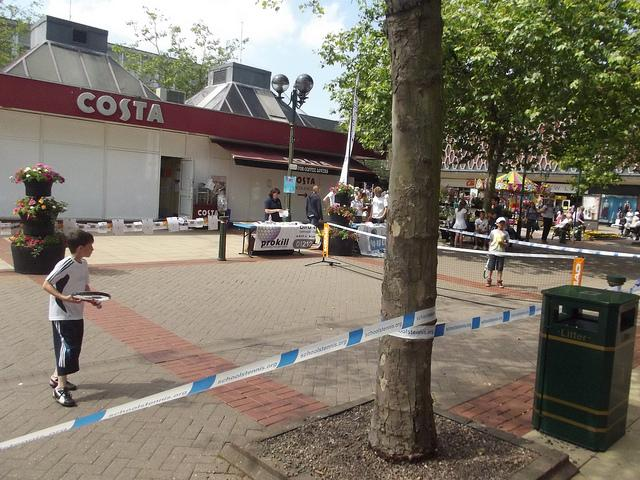What is the boy in the foreground doing? Please explain your reasoning. playing tennis. The boy is playing tennis. 